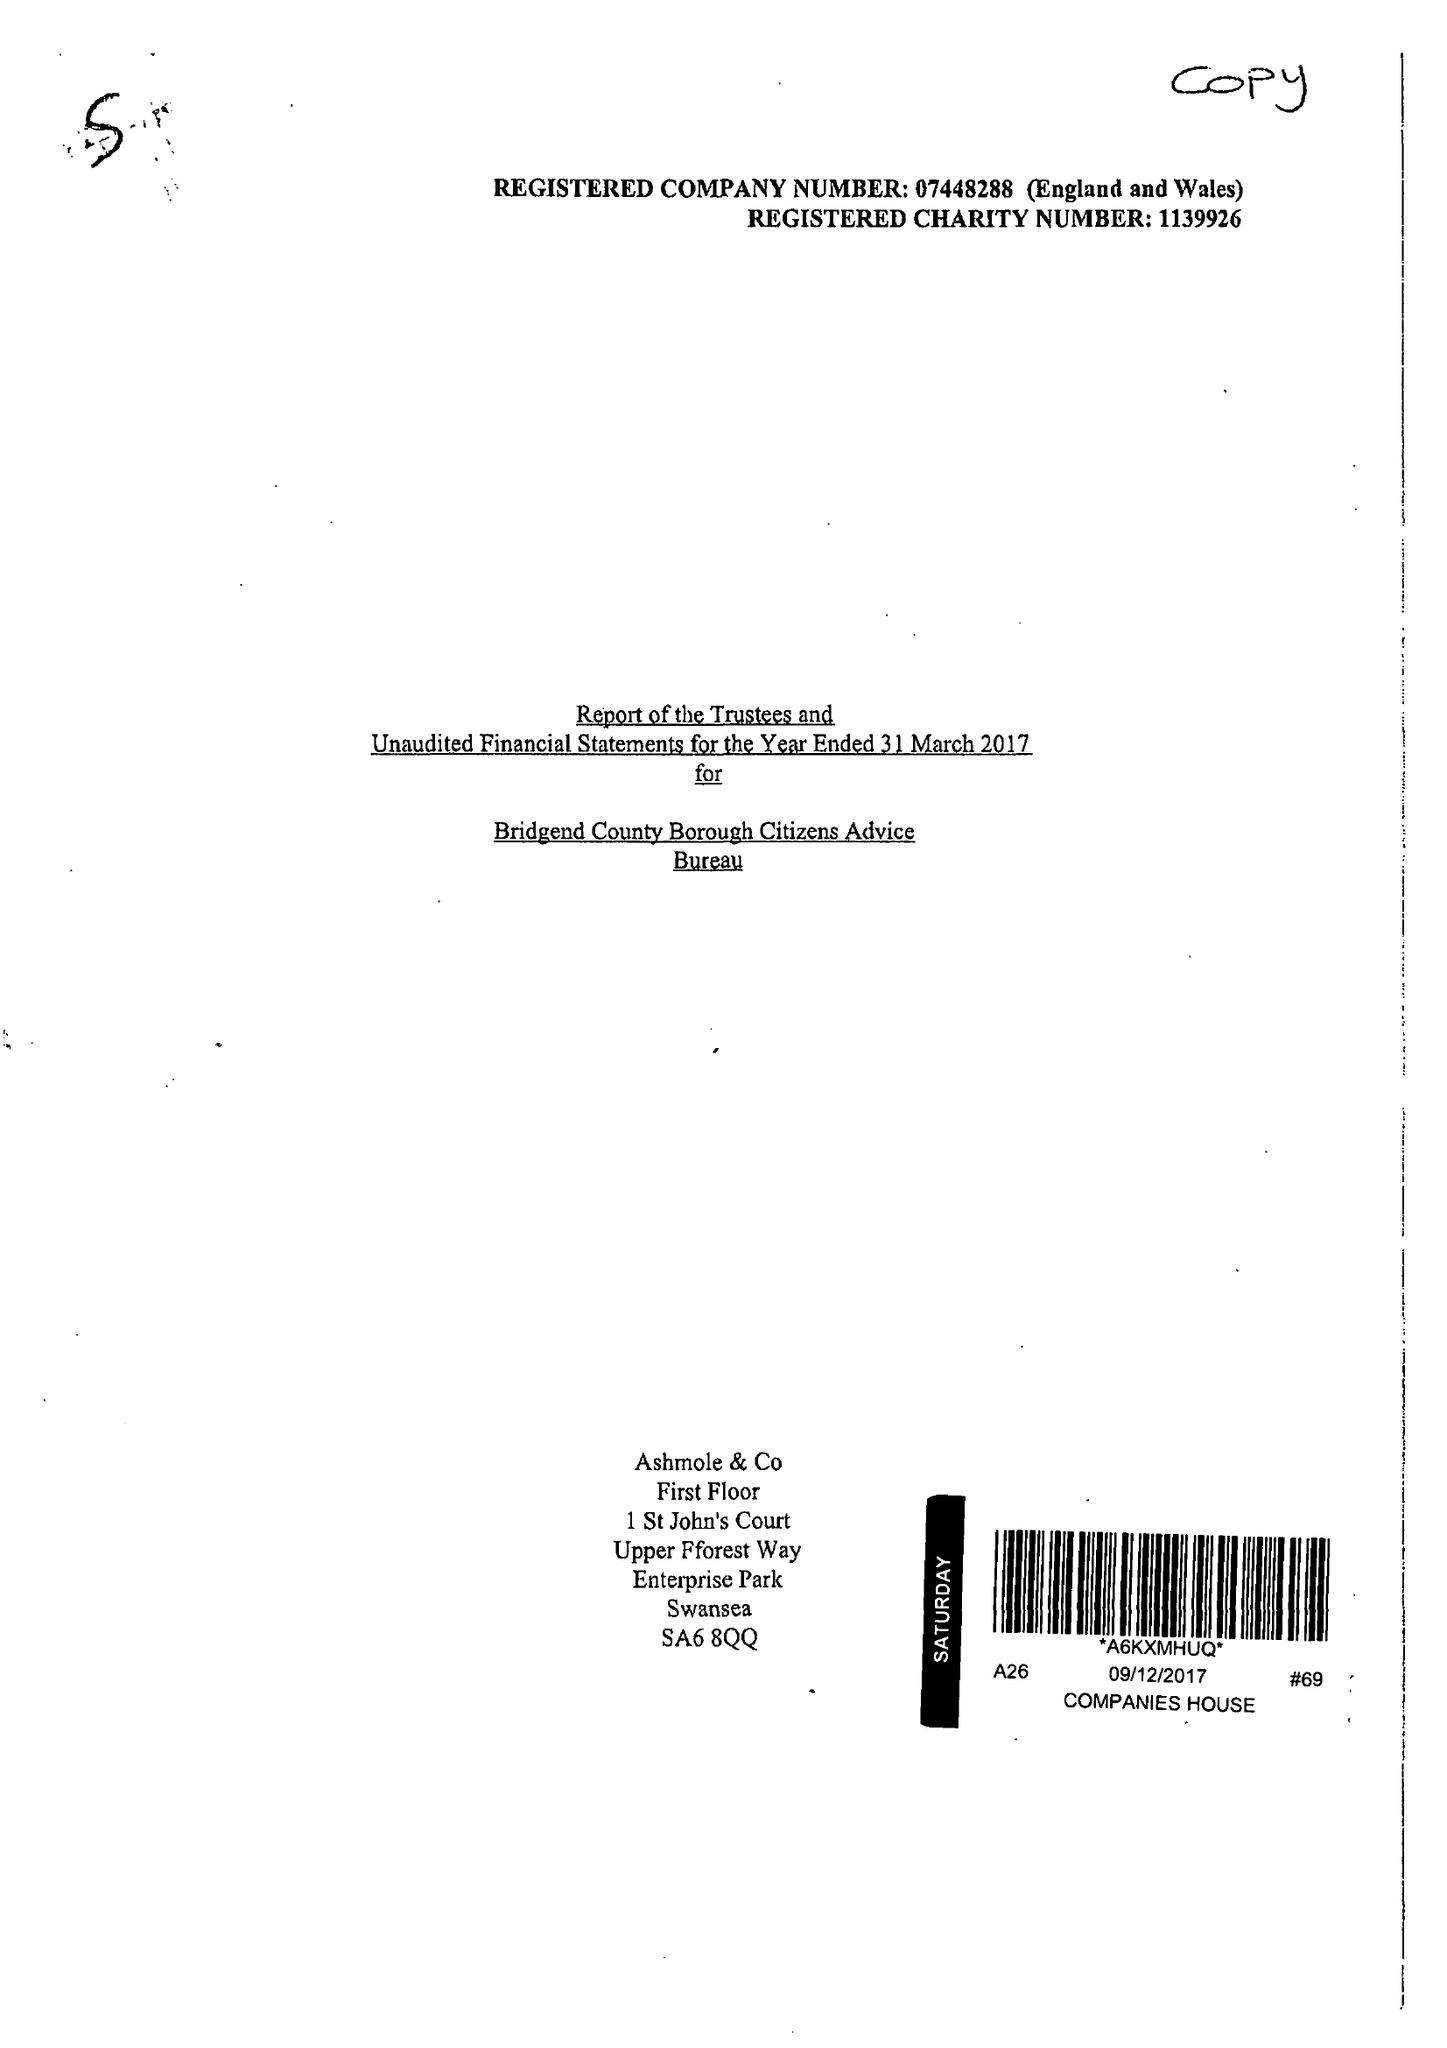What is the value for the charity_number?
Answer the question using a single word or phrase. 1139926 